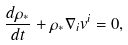Convert formula to latex. <formula><loc_0><loc_0><loc_500><loc_500>\frac { d \rho _ { * } } { d t } + \rho _ { * } \nabla _ { i } v ^ { i } = 0 ,</formula> 